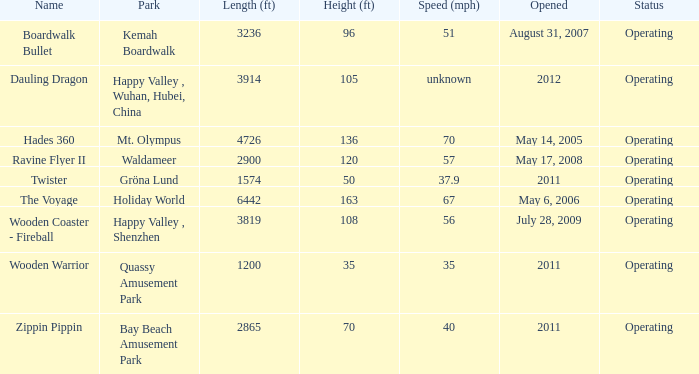What park is Boardwalk Bullet located in? Kemah Boardwalk. 